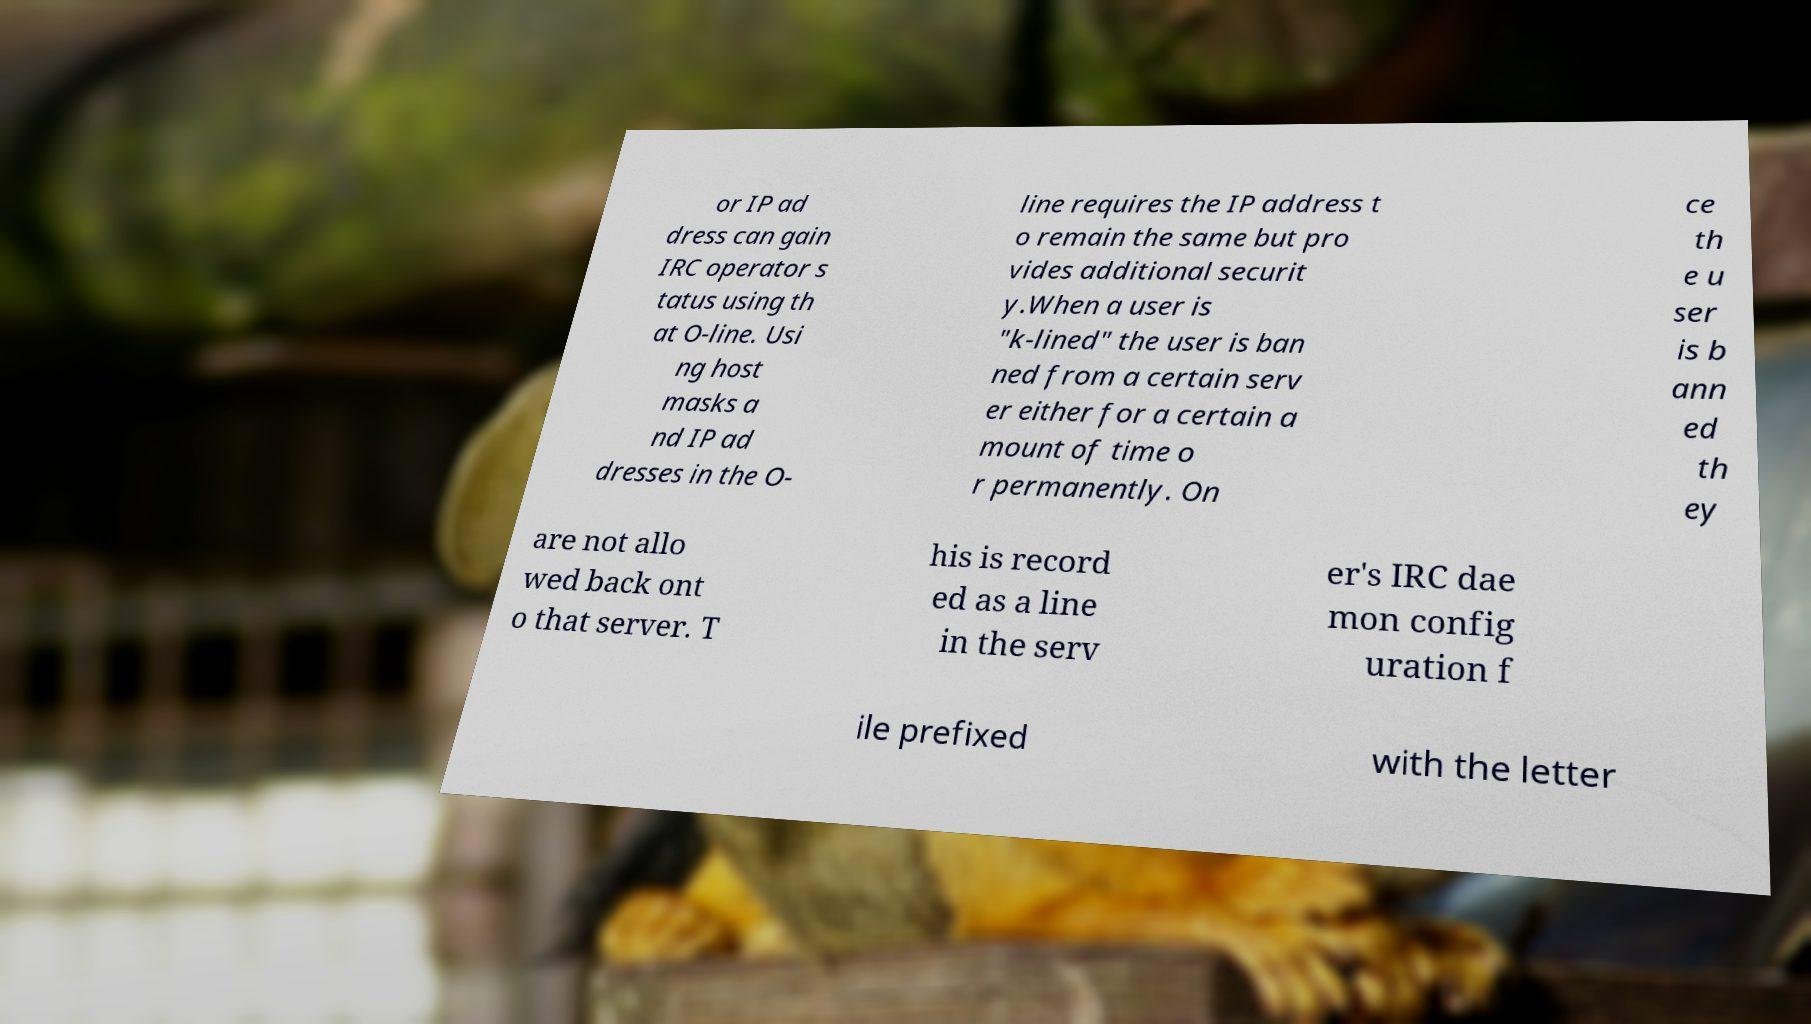Could you extract and type out the text from this image? or IP ad dress can gain IRC operator s tatus using th at O-line. Usi ng host masks a nd IP ad dresses in the O- line requires the IP address t o remain the same but pro vides additional securit y.When a user is "k-lined" the user is ban ned from a certain serv er either for a certain a mount of time o r permanently. On ce th e u ser is b ann ed th ey are not allo wed back ont o that server. T his is record ed as a line in the serv er's IRC dae mon config uration f ile prefixed with the letter 